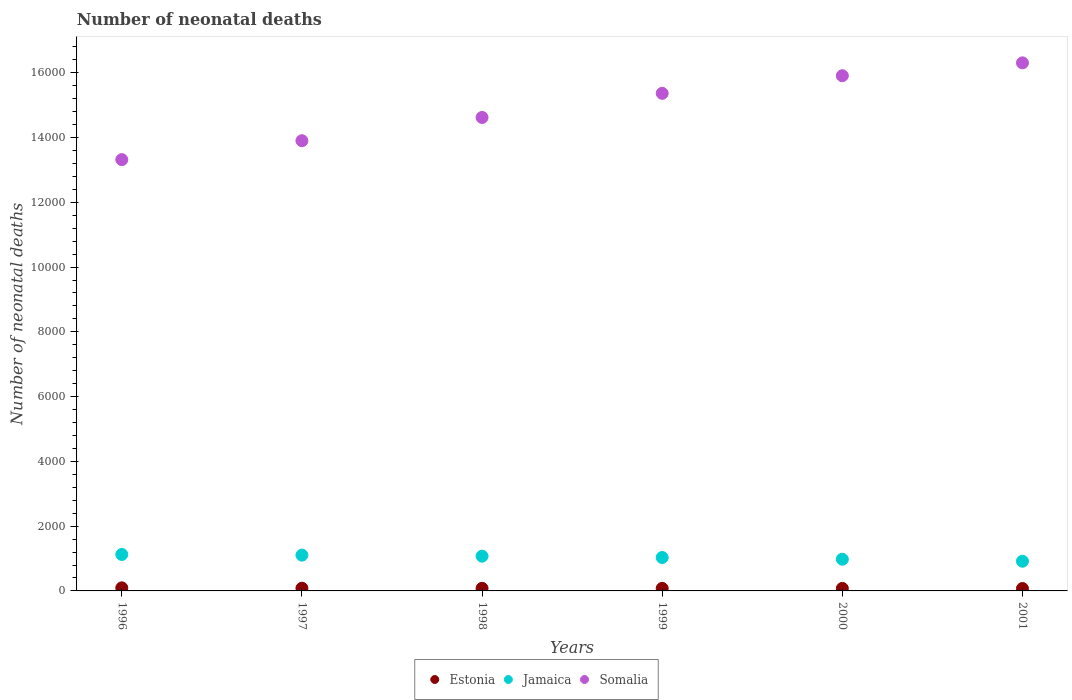How many different coloured dotlines are there?
Give a very brief answer. 3. What is the number of neonatal deaths in in Jamaica in 1996?
Make the answer very short. 1126. Across all years, what is the maximum number of neonatal deaths in in Estonia?
Make the answer very short. 95. Across all years, what is the minimum number of neonatal deaths in in Estonia?
Provide a succinct answer. 74. In which year was the number of neonatal deaths in in Estonia maximum?
Offer a terse response. 1996. In which year was the number of neonatal deaths in in Somalia minimum?
Your answer should be compact. 1996. What is the total number of neonatal deaths in in Jamaica in the graph?
Provide a succinct answer. 6232. What is the difference between the number of neonatal deaths in in Jamaica in 1996 and that in 2000?
Your answer should be compact. 147. What is the difference between the number of neonatal deaths in in Jamaica in 1998 and the number of neonatal deaths in in Estonia in 1996?
Provide a short and direct response. 978. What is the average number of neonatal deaths in in Estonia per year?
Give a very brief answer. 81.33. In the year 2000, what is the difference between the number of neonatal deaths in in Jamaica and number of neonatal deaths in in Somalia?
Your answer should be very brief. -1.49e+04. What is the ratio of the number of neonatal deaths in in Jamaica in 1996 to that in 1997?
Your response must be concise. 1.02. Is the number of neonatal deaths in in Somalia in 1996 less than that in 2001?
Make the answer very short. Yes. What is the difference between the highest and the lowest number of neonatal deaths in in Somalia?
Ensure brevity in your answer.  2988. In how many years, is the number of neonatal deaths in in Estonia greater than the average number of neonatal deaths in in Estonia taken over all years?
Offer a very short reply. 2. Does the number of neonatal deaths in in Estonia monotonically increase over the years?
Provide a succinct answer. No. Is the number of neonatal deaths in in Estonia strictly less than the number of neonatal deaths in in Somalia over the years?
Ensure brevity in your answer.  Yes. Does the graph contain grids?
Your answer should be compact. No. How many legend labels are there?
Make the answer very short. 3. What is the title of the graph?
Offer a very short reply. Number of neonatal deaths. Does "Mozambique" appear as one of the legend labels in the graph?
Your answer should be compact. No. What is the label or title of the X-axis?
Give a very brief answer. Years. What is the label or title of the Y-axis?
Offer a very short reply. Number of neonatal deaths. What is the Number of neonatal deaths in Estonia in 1996?
Your answer should be very brief. 95. What is the Number of neonatal deaths of Jamaica in 1996?
Ensure brevity in your answer.  1126. What is the Number of neonatal deaths in Somalia in 1996?
Provide a short and direct response. 1.33e+04. What is the Number of neonatal deaths of Jamaica in 1997?
Your response must be concise. 1105. What is the Number of neonatal deaths of Somalia in 1997?
Ensure brevity in your answer.  1.39e+04. What is the Number of neonatal deaths of Jamaica in 1998?
Provide a succinct answer. 1073. What is the Number of neonatal deaths of Somalia in 1998?
Your answer should be compact. 1.46e+04. What is the Number of neonatal deaths in Estonia in 1999?
Provide a succinct answer. 78. What is the Number of neonatal deaths of Jamaica in 1999?
Give a very brief answer. 1032. What is the Number of neonatal deaths in Somalia in 1999?
Offer a very short reply. 1.54e+04. What is the Number of neonatal deaths of Estonia in 2000?
Make the answer very short. 77. What is the Number of neonatal deaths of Jamaica in 2000?
Make the answer very short. 979. What is the Number of neonatal deaths in Somalia in 2000?
Give a very brief answer. 1.59e+04. What is the Number of neonatal deaths of Jamaica in 2001?
Your response must be concise. 917. What is the Number of neonatal deaths of Somalia in 2001?
Your answer should be compact. 1.63e+04. Across all years, what is the maximum Number of neonatal deaths in Jamaica?
Give a very brief answer. 1126. Across all years, what is the maximum Number of neonatal deaths of Somalia?
Your response must be concise. 1.63e+04. Across all years, what is the minimum Number of neonatal deaths in Jamaica?
Keep it short and to the point. 917. Across all years, what is the minimum Number of neonatal deaths in Somalia?
Ensure brevity in your answer.  1.33e+04. What is the total Number of neonatal deaths of Estonia in the graph?
Ensure brevity in your answer.  488. What is the total Number of neonatal deaths in Jamaica in the graph?
Give a very brief answer. 6232. What is the total Number of neonatal deaths in Somalia in the graph?
Your answer should be compact. 8.94e+04. What is the difference between the Number of neonatal deaths in Somalia in 1996 and that in 1997?
Offer a terse response. -584. What is the difference between the Number of neonatal deaths of Estonia in 1996 and that in 1998?
Provide a short and direct response. 15. What is the difference between the Number of neonatal deaths in Somalia in 1996 and that in 1998?
Your answer should be very brief. -1302. What is the difference between the Number of neonatal deaths of Jamaica in 1996 and that in 1999?
Give a very brief answer. 94. What is the difference between the Number of neonatal deaths in Somalia in 1996 and that in 1999?
Your answer should be very brief. -2047. What is the difference between the Number of neonatal deaths of Jamaica in 1996 and that in 2000?
Provide a short and direct response. 147. What is the difference between the Number of neonatal deaths in Somalia in 1996 and that in 2000?
Your answer should be very brief. -2591. What is the difference between the Number of neonatal deaths of Estonia in 1996 and that in 2001?
Your response must be concise. 21. What is the difference between the Number of neonatal deaths of Jamaica in 1996 and that in 2001?
Provide a short and direct response. 209. What is the difference between the Number of neonatal deaths of Somalia in 1996 and that in 2001?
Ensure brevity in your answer.  -2988. What is the difference between the Number of neonatal deaths in Jamaica in 1997 and that in 1998?
Your response must be concise. 32. What is the difference between the Number of neonatal deaths of Somalia in 1997 and that in 1998?
Make the answer very short. -718. What is the difference between the Number of neonatal deaths in Somalia in 1997 and that in 1999?
Give a very brief answer. -1463. What is the difference between the Number of neonatal deaths of Estonia in 1997 and that in 2000?
Keep it short and to the point. 7. What is the difference between the Number of neonatal deaths in Jamaica in 1997 and that in 2000?
Offer a terse response. 126. What is the difference between the Number of neonatal deaths in Somalia in 1997 and that in 2000?
Offer a terse response. -2007. What is the difference between the Number of neonatal deaths in Jamaica in 1997 and that in 2001?
Offer a very short reply. 188. What is the difference between the Number of neonatal deaths in Somalia in 1997 and that in 2001?
Make the answer very short. -2404. What is the difference between the Number of neonatal deaths in Jamaica in 1998 and that in 1999?
Provide a succinct answer. 41. What is the difference between the Number of neonatal deaths in Somalia in 1998 and that in 1999?
Your answer should be very brief. -745. What is the difference between the Number of neonatal deaths of Jamaica in 1998 and that in 2000?
Your response must be concise. 94. What is the difference between the Number of neonatal deaths of Somalia in 1998 and that in 2000?
Your response must be concise. -1289. What is the difference between the Number of neonatal deaths of Jamaica in 1998 and that in 2001?
Your answer should be very brief. 156. What is the difference between the Number of neonatal deaths in Somalia in 1998 and that in 2001?
Your answer should be very brief. -1686. What is the difference between the Number of neonatal deaths of Jamaica in 1999 and that in 2000?
Your answer should be compact. 53. What is the difference between the Number of neonatal deaths of Somalia in 1999 and that in 2000?
Offer a very short reply. -544. What is the difference between the Number of neonatal deaths of Estonia in 1999 and that in 2001?
Offer a very short reply. 4. What is the difference between the Number of neonatal deaths of Jamaica in 1999 and that in 2001?
Your response must be concise. 115. What is the difference between the Number of neonatal deaths of Somalia in 1999 and that in 2001?
Keep it short and to the point. -941. What is the difference between the Number of neonatal deaths in Estonia in 2000 and that in 2001?
Your answer should be very brief. 3. What is the difference between the Number of neonatal deaths in Somalia in 2000 and that in 2001?
Your answer should be compact. -397. What is the difference between the Number of neonatal deaths of Estonia in 1996 and the Number of neonatal deaths of Jamaica in 1997?
Offer a terse response. -1010. What is the difference between the Number of neonatal deaths of Estonia in 1996 and the Number of neonatal deaths of Somalia in 1997?
Provide a succinct answer. -1.38e+04. What is the difference between the Number of neonatal deaths of Jamaica in 1996 and the Number of neonatal deaths of Somalia in 1997?
Give a very brief answer. -1.28e+04. What is the difference between the Number of neonatal deaths in Estonia in 1996 and the Number of neonatal deaths in Jamaica in 1998?
Make the answer very short. -978. What is the difference between the Number of neonatal deaths of Estonia in 1996 and the Number of neonatal deaths of Somalia in 1998?
Ensure brevity in your answer.  -1.45e+04. What is the difference between the Number of neonatal deaths of Jamaica in 1996 and the Number of neonatal deaths of Somalia in 1998?
Your answer should be very brief. -1.35e+04. What is the difference between the Number of neonatal deaths in Estonia in 1996 and the Number of neonatal deaths in Jamaica in 1999?
Your response must be concise. -937. What is the difference between the Number of neonatal deaths in Estonia in 1996 and the Number of neonatal deaths in Somalia in 1999?
Your answer should be compact. -1.53e+04. What is the difference between the Number of neonatal deaths in Jamaica in 1996 and the Number of neonatal deaths in Somalia in 1999?
Give a very brief answer. -1.42e+04. What is the difference between the Number of neonatal deaths in Estonia in 1996 and the Number of neonatal deaths in Jamaica in 2000?
Your answer should be very brief. -884. What is the difference between the Number of neonatal deaths of Estonia in 1996 and the Number of neonatal deaths of Somalia in 2000?
Your answer should be compact. -1.58e+04. What is the difference between the Number of neonatal deaths of Jamaica in 1996 and the Number of neonatal deaths of Somalia in 2000?
Give a very brief answer. -1.48e+04. What is the difference between the Number of neonatal deaths in Estonia in 1996 and the Number of neonatal deaths in Jamaica in 2001?
Your answer should be very brief. -822. What is the difference between the Number of neonatal deaths of Estonia in 1996 and the Number of neonatal deaths of Somalia in 2001?
Keep it short and to the point. -1.62e+04. What is the difference between the Number of neonatal deaths in Jamaica in 1996 and the Number of neonatal deaths in Somalia in 2001?
Provide a short and direct response. -1.52e+04. What is the difference between the Number of neonatal deaths in Estonia in 1997 and the Number of neonatal deaths in Jamaica in 1998?
Your answer should be very brief. -989. What is the difference between the Number of neonatal deaths in Estonia in 1997 and the Number of neonatal deaths in Somalia in 1998?
Offer a terse response. -1.45e+04. What is the difference between the Number of neonatal deaths in Jamaica in 1997 and the Number of neonatal deaths in Somalia in 1998?
Keep it short and to the point. -1.35e+04. What is the difference between the Number of neonatal deaths in Estonia in 1997 and the Number of neonatal deaths in Jamaica in 1999?
Your answer should be very brief. -948. What is the difference between the Number of neonatal deaths in Estonia in 1997 and the Number of neonatal deaths in Somalia in 1999?
Your answer should be compact. -1.53e+04. What is the difference between the Number of neonatal deaths of Jamaica in 1997 and the Number of neonatal deaths of Somalia in 1999?
Provide a short and direct response. -1.43e+04. What is the difference between the Number of neonatal deaths of Estonia in 1997 and the Number of neonatal deaths of Jamaica in 2000?
Make the answer very short. -895. What is the difference between the Number of neonatal deaths in Estonia in 1997 and the Number of neonatal deaths in Somalia in 2000?
Your answer should be compact. -1.58e+04. What is the difference between the Number of neonatal deaths in Jamaica in 1997 and the Number of neonatal deaths in Somalia in 2000?
Ensure brevity in your answer.  -1.48e+04. What is the difference between the Number of neonatal deaths in Estonia in 1997 and the Number of neonatal deaths in Jamaica in 2001?
Ensure brevity in your answer.  -833. What is the difference between the Number of neonatal deaths in Estonia in 1997 and the Number of neonatal deaths in Somalia in 2001?
Keep it short and to the point. -1.62e+04. What is the difference between the Number of neonatal deaths of Jamaica in 1997 and the Number of neonatal deaths of Somalia in 2001?
Keep it short and to the point. -1.52e+04. What is the difference between the Number of neonatal deaths of Estonia in 1998 and the Number of neonatal deaths of Jamaica in 1999?
Provide a short and direct response. -952. What is the difference between the Number of neonatal deaths of Estonia in 1998 and the Number of neonatal deaths of Somalia in 1999?
Keep it short and to the point. -1.53e+04. What is the difference between the Number of neonatal deaths in Jamaica in 1998 and the Number of neonatal deaths in Somalia in 1999?
Make the answer very short. -1.43e+04. What is the difference between the Number of neonatal deaths in Estonia in 1998 and the Number of neonatal deaths in Jamaica in 2000?
Your answer should be compact. -899. What is the difference between the Number of neonatal deaths in Estonia in 1998 and the Number of neonatal deaths in Somalia in 2000?
Your response must be concise. -1.58e+04. What is the difference between the Number of neonatal deaths in Jamaica in 1998 and the Number of neonatal deaths in Somalia in 2000?
Your answer should be very brief. -1.48e+04. What is the difference between the Number of neonatal deaths in Estonia in 1998 and the Number of neonatal deaths in Jamaica in 2001?
Your answer should be compact. -837. What is the difference between the Number of neonatal deaths in Estonia in 1998 and the Number of neonatal deaths in Somalia in 2001?
Your response must be concise. -1.62e+04. What is the difference between the Number of neonatal deaths of Jamaica in 1998 and the Number of neonatal deaths of Somalia in 2001?
Your answer should be very brief. -1.52e+04. What is the difference between the Number of neonatal deaths in Estonia in 1999 and the Number of neonatal deaths in Jamaica in 2000?
Offer a very short reply. -901. What is the difference between the Number of neonatal deaths of Estonia in 1999 and the Number of neonatal deaths of Somalia in 2000?
Provide a short and direct response. -1.58e+04. What is the difference between the Number of neonatal deaths of Jamaica in 1999 and the Number of neonatal deaths of Somalia in 2000?
Offer a terse response. -1.49e+04. What is the difference between the Number of neonatal deaths of Estonia in 1999 and the Number of neonatal deaths of Jamaica in 2001?
Your answer should be very brief. -839. What is the difference between the Number of neonatal deaths of Estonia in 1999 and the Number of neonatal deaths of Somalia in 2001?
Your response must be concise. -1.62e+04. What is the difference between the Number of neonatal deaths in Jamaica in 1999 and the Number of neonatal deaths in Somalia in 2001?
Your answer should be compact. -1.53e+04. What is the difference between the Number of neonatal deaths in Estonia in 2000 and the Number of neonatal deaths in Jamaica in 2001?
Your answer should be compact. -840. What is the difference between the Number of neonatal deaths of Estonia in 2000 and the Number of neonatal deaths of Somalia in 2001?
Ensure brevity in your answer.  -1.62e+04. What is the difference between the Number of neonatal deaths of Jamaica in 2000 and the Number of neonatal deaths of Somalia in 2001?
Make the answer very short. -1.53e+04. What is the average Number of neonatal deaths of Estonia per year?
Provide a short and direct response. 81.33. What is the average Number of neonatal deaths of Jamaica per year?
Your answer should be compact. 1038.67. What is the average Number of neonatal deaths of Somalia per year?
Ensure brevity in your answer.  1.49e+04. In the year 1996, what is the difference between the Number of neonatal deaths in Estonia and Number of neonatal deaths in Jamaica?
Your answer should be very brief. -1031. In the year 1996, what is the difference between the Number of neonatal deaths of Estonia and Number of neonatal deaths of Somalia?
Your answer should be very brief. -1.32e+04. In the year 1996, what is the difference between the Number of neonatal deaths in Jamaica and Number of neonatal deaths in Somalia?
Your response must be concise. -1.22e+04. In the year 1997, what is the difference between the Number of neonatal deaths in Estonia and Number of neonatal deaths in Jamaica?
Your response must be concise. -1021. In the year 1997, what is the difference between the Number of neonatal deaths of Estonia and Number of neonatal deaths of Somalia?
Offer a very short reply. -1.38e+04. In the year 1997, what is the difference between the Number of neonatal deaths of Jamaica and Number of neonatal deaths of Somalia?
Your answer should be very brief. -1.28e+04. In the year 1998, what is the difference between the Number of neonatal deaths of Estonia and Number of neonatal deaths of Jamaica?
Your response must be concise. -993. In the year 1998, what is the difference between the Number of neonatal deaths in Estonia and Number of neonatal deaths in Somalia?
Offer a very short reply. -1.45e+04. In the year 1998, what is the difference between the Number of neonatal deaths in Jamaica and Number of neonatal deaths in Somalia?
Your response must be concise. -1.35e+04. In the year 1999, what is the difference between the Number of neonatal deaths of Estonia and Number of neonatal deaths of Jamaica?
Make the answer very short. -954. In the year 1999, what is the difference between the Number of neonatal deaths in Estonia and Number of neonatal deaths in Somalia?
Keep it short and to the point. -1.53e+04. In the year 1999, what is the difference between the Number of neonatal deaths in Jamaica and Number of neonatal deaths in Somalia?
Provide a short and direct response. -1.43e+04. In the year 2000, what is the difference between the Number of neonatal deaths in Estonia and Number of neonatal deaths in Jamaica?
Keep it short and to the point. -902. In the year 2000, what is the difference between the Number of neonatal deaths of Estonia and Number of neonatal deaths of Somalia?
Ensure brevity in your answer.  -1.58e+04. In the year 2000, what is the difference between the Number of neonatal deaths in Jamaica and Number of neonatal deaths in Somalia?
Ensure brevity in your answer.  -1.49e+04. In the year 2001, what is the difference between the Number of neonatal deaths in Estonia and Number of neonatal deaths in Jamaica?
Ensure brevity in your answer.  -843. In the year 2001, what is the difference between the Number of neonatal deaths in Estonia and Number of neonatal deaths in Somalia?
Your answer should be very brief. -1.62e+04. In the year 2001, what is the difference between the Number of neonatal deaths of Jamaica and Number of neonatal deaths of Somalia?
Your answer should be very brief. -1.54e+04. What is the ratio of the Number of neonatal deaths of Estonia in 1996 to that in 1997?
Make the answer very short. 1.13. What is the ratio of the Number of neonatal deaths in Jamaica in 1996 to that in 1997?
Your answer should be compact. 1.02. What is the ratio of the Number of neonatal deaths of Somalia in 1996 to that in 1997?
Your response must be concise. 0.96. What is the ratio of the Number of neonatal deaths in Estonia in 1996 to that in 1998?
Provide a succinct answer. 1.19. What is the ratio of the Number of neonatal deaths in Jamaica in 1996 to that in 1998?
Offer a terse response. 1.05. What is the ratio of the Number of neonatal deaths of Somalia in 1996 to that in 1998?
Your response must be concise. 0.91. What is the ratio of the Number of neonatal deaths of Estonia in 1996 to that in 1999?
Offer a terse response. 1.22. What is the ratio of the Number of neonatal deaths in Jamaica in 1996 to that in 1999?
Ensure brevity in your answer.  1.09. What is the ratio of the Number of neonatal deaths in Somalia in 1996 to that in 1999?
Offer a terse response. 0.87. What is the ratio of the Number of neonatal deaths in Estonia in 1996 to that in 2000?
Give a very brief answer. 1.23. What is the ratio of the Number of neonatal deaths of Jamaica in 1996 to that in 2000?
Your answer should be very brief. 1.15. What is the ratio of the Number of neonatal deaths of Somalia in 1996 to that in 2000?
Ensure brevity in your answer.  0.84. What is the ratio of the Number of neonatal deaths in Estonia in 1996 to that in 2001?
Your answer should be compact. 1.28. What is the ratio of the Number of neonatal deaths of Jamaica in 1996 to that in 2001?
Your answer should be compact. 1.23. What is the ratio of the Number of neonatal deaths of Somalia in 1996 to that in 2001?
Your answer should be compact. 0.82. What is the ratio of the Number of neonatal deaths in Jamaica in 1997 to that in 1998?
Ensure brevity in your answer.  1.03. What is the ratio of the Number of neonatal deaths of Somalia in 1997 to that in 1998?
Make the answer very short. 0.95. What is the ratio of the Number of neonatal deaths in Estonia in 1997 to that in 1999?
Make the answer very short. 1.08. What is the ratio of the Number of neonatal deaths of Jamaica in 1997 to that in 1999?
Provide a short and direct response. 1.07. What is the ratio of the Number of neonatal deaths in Somalia in 1997 to that in 1999?
Your answer should be very brief. 0.9. What is the ratio of the Number of neonatal deaths of Jamaica in 1997 to that in 2000?
Keep it short and to the point. 1.13. What is the ratio of the Number of neonatal deaths of Somalia in 1997 to that in 2000?
Ensure brevity in your answer.  0.87. What is the ratio of the Number of neonatal deaths in Estonia in 1997 to that in 2001?
Provide a succinct answer. 1.14. What is the ratio of the Number of neonatal deaths of Jamaica in 1997 to that in 2001?
Your answer should be compact. 1.21. What is the ratio of the Number of neonatal deaths in Somalia in 1997 to that in 2001?
Ensure brevity in your answer.  0.85. What is the ratio of the Number of neonatal deaths of Estonia in 1998 to that in 1999?
Provide a succinct answer. 1.03. What is the ratio of the Number of neonatal deaths in Jamaica in 1998 to that in 1999?
Your response must be concise. 1.04. What is the ratio of the Number of neonatal deaths in Somalia in 1998 to that in 1999?
Offer a terse response. 0.95. What is the ratio of the Number of neonatal deaths in Estonia in 1998 to that in 2000?
Offer a very short reply. 1.04. What is the ratio of the Number of neonatal deaths in Jamaica in 1998 to that in 2000?
Give a very brief answer. 1.1. What is the ratio of the Number of neonatal deaths of Somalia in 1998 to that in 2000?
Provide a succinct answer. 0.92. What is the ratio of the Number of neonatal deaths of Estonia in 1998 to that in 2001?
Provide a succinct answer. 1.08. What is the ratio of the Number of neonatal deaths of Jamaica in 1998 to that in 2001?
Offer a terse response. 1.17. What is the ratio of the Number of neonatal deaths in Somalia in 1998 to that in 2001?
Give a very brief answer. 0.9. What is the ratio of the Number of neonatal deaths in Jamaica in 1999 to that in 2000?
Provide a short and direct response. 1.05. What is the ratio of the Number of neonatal deaths in Somalia in 1999 to that in 2000?
Your response must be concise. 0.97. What is the ratio of the Number of neonatal deaths of Estonia in 1999 to that in 2001?
Offer a very short reply. 1.05. What is the ratio of the Number of neonatal deaths in Jamaica in 1999 to that in 2001?
Provide a succinct answer. 1.13. What is the ratio of the Number of neonatal deaths in Somalia in 1999 to that in 2001?
Offer a terse response. 0.94. What is the ratio of the Number of neonatal deaths of Estonia in 2000 to that in 2001?
Give a very brief answer. 1.04. What is the ratio of the Number of neonatal deaths in Jamaica in 2000 to that in 2001?
Keep it short and to the point. 1.07. What is the ratio of the Number of neonatal deaths of Somalia in 2000 to that in 2001?
Provide a short and direct response. 0.98. What is the difference between the highest and the second highest Number of neonatal deaths in Estonia?
Keep it short and to the point. 11. What is the difference between the highest and the second highest Number of neonatal deaths in Somalia?
Keep it short and to the point. 397. What is the difference between the highest and the lowest Number of neonatal deaths in Jamaica?
Ensure brevity in your answer.  209. What is the difference between the highest and the lowest Number of neonatal deaths in Somalia?
Provide a succinct answer. 2988. 